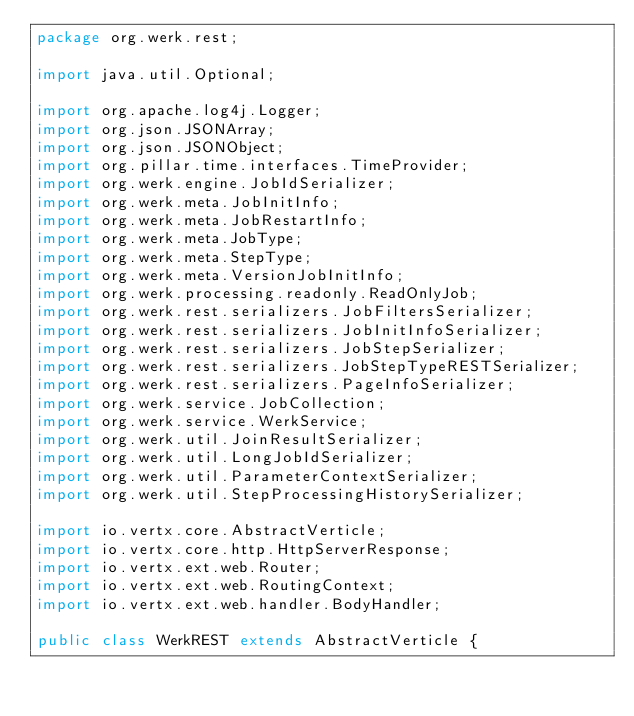Convert code to text. <code><loc_0><loc_0><loc_500><loc_500><_Java_>package org.werk.rest;

import java.util.Optional;

import org.apache.log4j.Logger;
import org.json.JSONArray;
import org.json.JSONObject;
import org.pillar.time.interfaces.TimeProvider;
import org.werk.engine.JobIdSerializer;
import org.werk.meta.JobInitInfo;
import org.werk.meta.JobRestartInfo;
import org.werk.meta.JobType;
import org.werk.meta.StepType;
import org.werk.meta.VersionJobInitInfo;
import org.werk.processing.readonly.ReadOnlyJob;
import org.werk.rest.serializers.JobFiltersSerializer;
import org.werk.rest.serializers.JobInitInfoSerializer;
import org.werk.rest.serializers.JobStepSerializer;
import org.werk.rest.serializers.JobStepTypeRESTSerializer;
import org.werk.rest.serializers.PageInfoSerializer;
import org.werk.service.JobCollection;
import org.werk.service.WerkService;
import org.werk.util.JoinResultSerializer;
import org.werk.util.LongJobIdSerializer;
import org.werk.util.ParameterContextSerializer;
import org.werk.util.StepProcessingHistorySerializer;

import io.vertx.core.AbstractVerticle;
import io.vertx.core.http.HttpServerResponse;
import io.vertx.ext.web.Router;
import io.vertx.ext.web.RoutingContext;
import io.vertx.ext.web.handler.BodyHandler;

public class WerkREST extends AbstractVerticle {</code> 